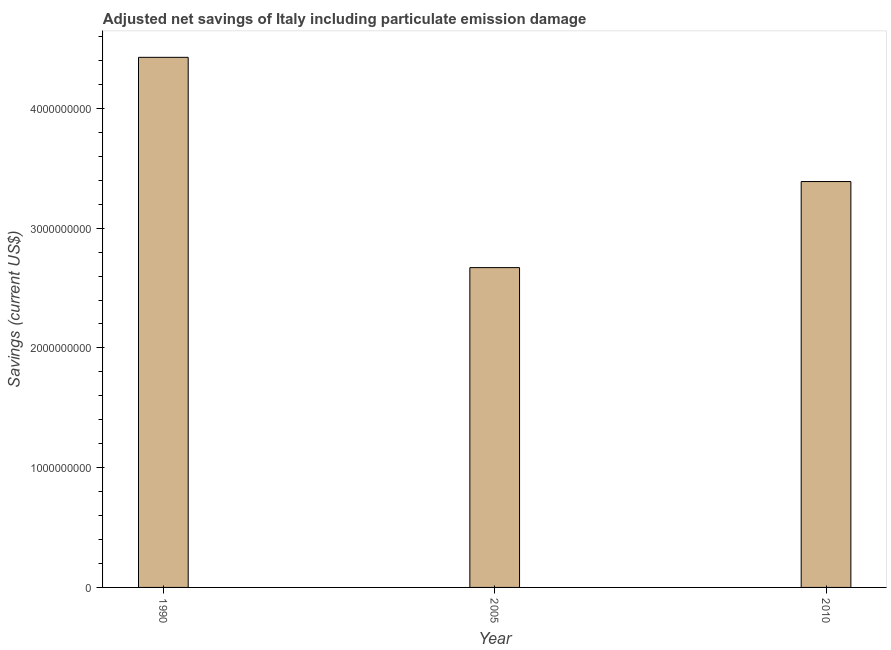Does the graph contain any zero values?
Provide a succinct answer. No. Does the graph contain grids?
Offer a very short reply. No. What is the title of the graph?
Make the answer very short. Adjusted net savings of Italy including particulate emission damage. What is the label or title of the X-axis?
Keep it short and to the point. Year. What is the label or title of the Y-axis?
Your answer should be very brief. Savings (current US$). What is the adjusted net savings in 1990?
Give a very brief answer. 4.43e+09. Across all years, what is the maximum adjusted net savings?
Your answer should be compact. 4.43e+09. Across all years, what is the minimum adjusted net savings?
Keep it short and to the point. 2.67e+09. In which year was the adjusted net savings maximum?
Keep it short and to the point. 1990. What is the sum of the adjusted net savings?
Make the answer very short. 1.05e+1. What is the difference between the adjusted net savings in 2005 and 2010?
Make the answer very short. -7.19e+08. What is the average adjusted net savings per year?
Keep it short and to the point. 3.50e+09. What is the median adjusted net savings?
Keep it short and to the point. 3.39e+09. In how many years, is the adjusted net savings greater than 3800000000 US$?
Provide a succinct answer. 1. What is the ratio of the adjusted net savings in 1990 to that in 2010?
Make the answer very short. 1.31. What is the difference between the highest and the second highest adjusted net savings?
Offer a terse response. 1.04e+09. Is the sum of the adjusted net savings in 1990 and 2010 greater than the maximum adjusted net savings across all years?
Provide a succinct answer. Yes. What is the difference between the highest and the lowest adjusted net savings?
Keep it short and to the point. 1.76e+09. In how many years, is the adjusted net savings greater than the average adjusted net savings taken over all years?
Ensure brevity in your answer.  1. What is the difference between two consecutive major ticks on the Y-axis?
Your answer should be compact. 1.00e+09. Are the values on the major ticks of Y-axis written in scientific E-notation?
Provide a short and direct response. No. What is the Savings (current US$) in 1990?
Give a very brief answer. 4.43e+09. What is the Savings (current US$) in 2005?
Your answer should be very brief. 2.67e+09. What is the Savings (current US$) of 2010?
Provide a short and direct response. 3.39e+09. What is the difference between the Savings (current US$) in 1990 and 2005?
Keep it short and to the point. 1.76e+09. What is the difference between the Savings (current US$) in 1990 and 2010?
Ensure brevity in your answer.  1.04e+09. What is the difference between the Savings (current US$) in 2005 and 2010?
Make the answer very short. -7.19e+08. What is the ratio of the Savings (current US$) in 1990 to that in 2005?
Make the answer very short. 1.66. What is the ratio of the Savings (current US$) in 1990 to that in 2010?
Give a very brief answer. 1.31. What is the ratio of the Savings (current US$) in 2005 to that in 2010?
Offer a very short reply. 0.79. 